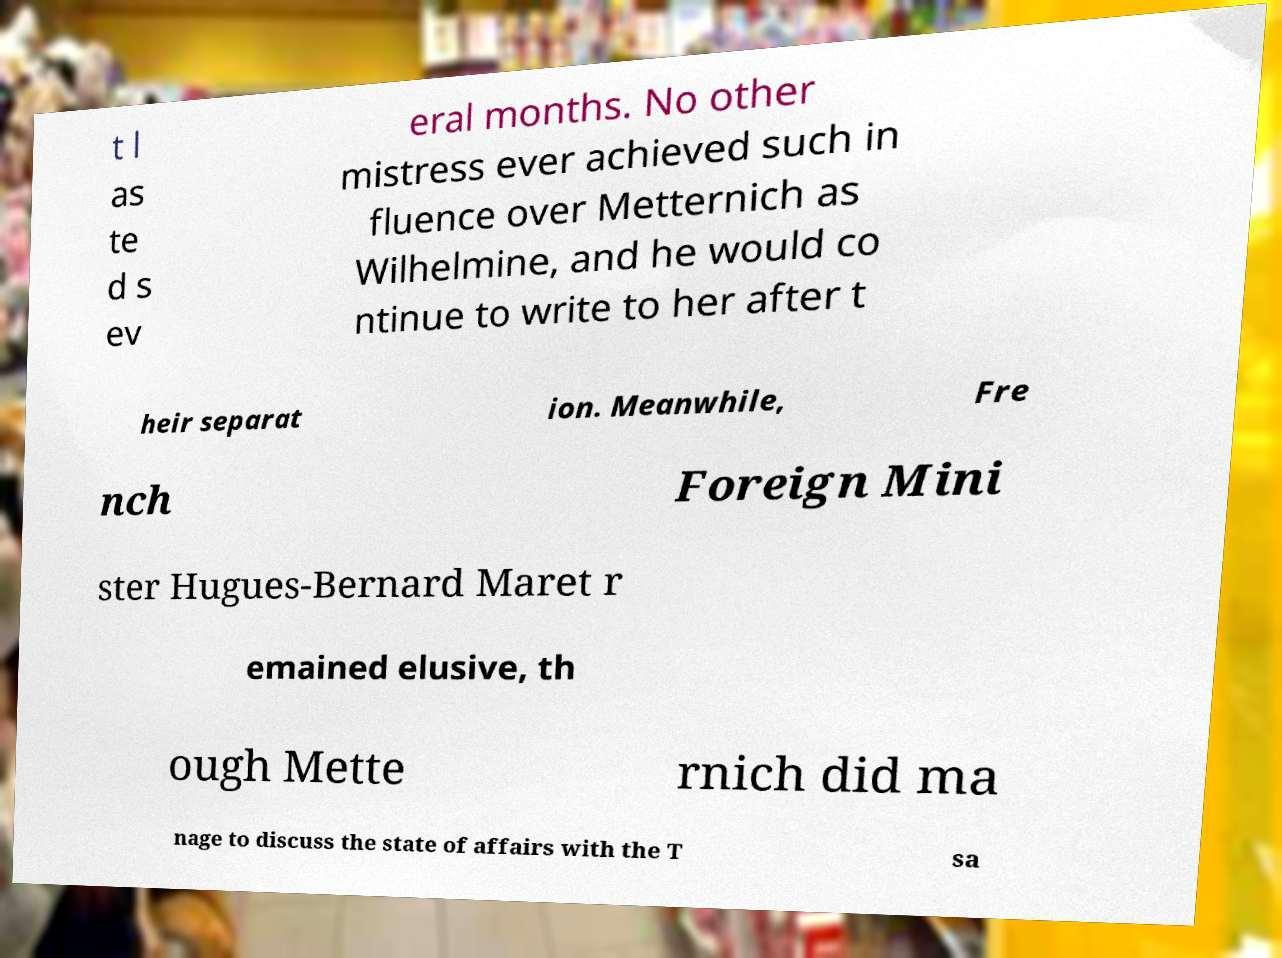I need the written content from this picture converted into text. Can you do that? t l as te d s ev eral months. No other mistress ever achieved such in fluence over Metternich as Wilhelmine, and he would co ntinue to write to her after t heir separat ion. Meanwhile, Fre nch Foreign Mini ster Hugues-Bernard Maret r emained elusive, th ough Mette rnich did ma nage to discuss the state of affairs with the T sa 